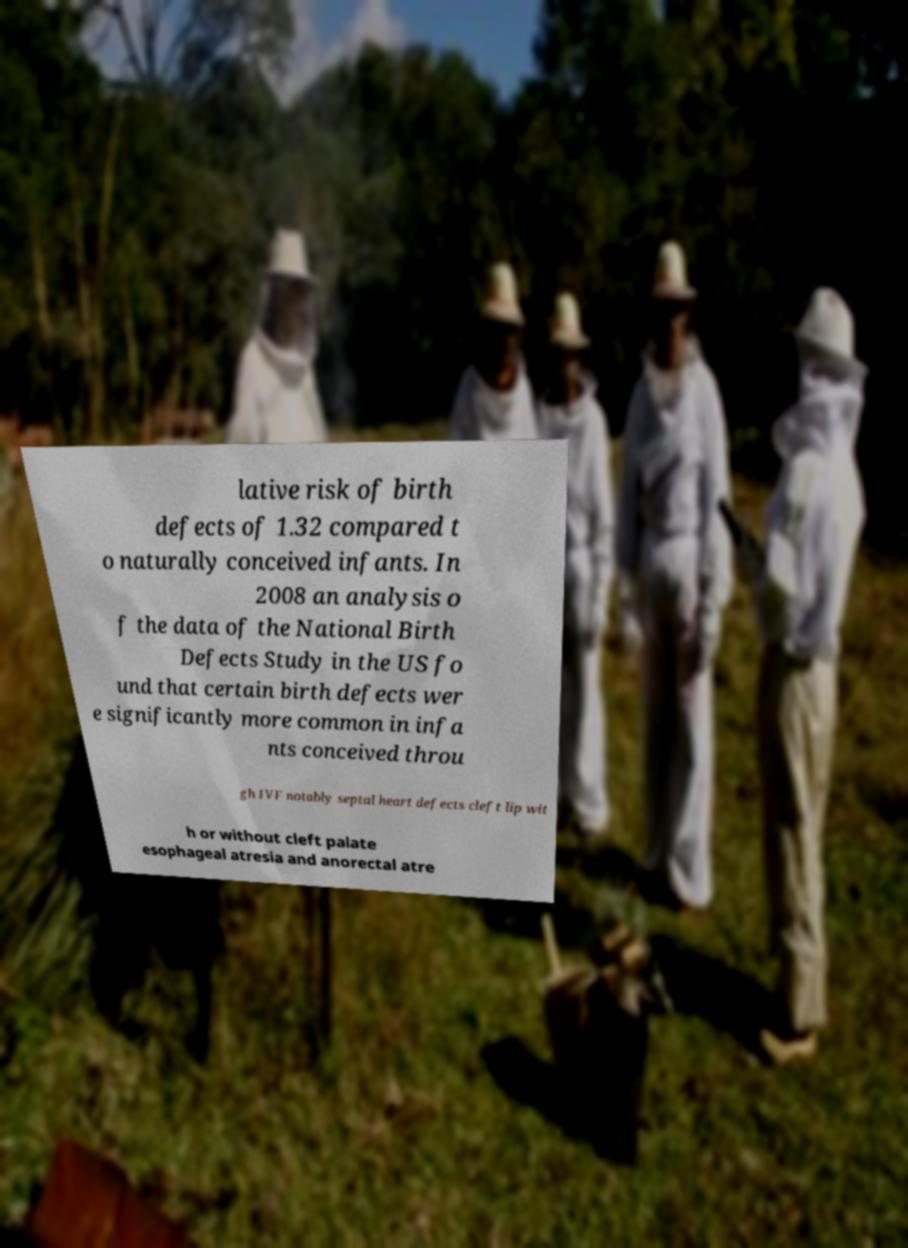There's text embedded in this image that I need extracted. Can you transcribe it verbatim? lative risk of birth defects of 1.32 compared t o naturally conceived infants. In 2008 an analysis o f the data of the National Birth Defects Study in the US fo und that certain birth defects wer e significantly more common in infa nts conceived throu gh IVF notably septal heart defects cleft lip wit h or without cleft palate esophageal atresia and anorectal atre 